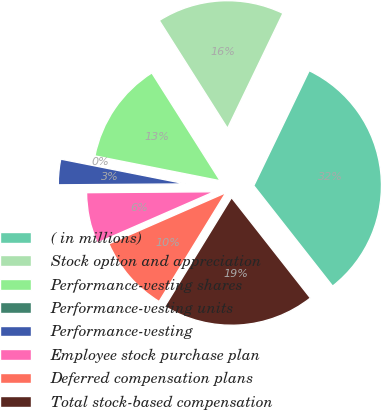<chart> <loc_0><loc_0><loc_500><loc_500><pie_chart><fcel>( in millions)<fcel>Stock option and appreciation<fcel>Performance-vesting shares<fcel>Performance-vesting units<fcel>Performance-vesting<fcel>Employee stock purchase plan<fcel>Deferred compensation plans<fcel>Total stock-based compensation<nl><fcel>32.26%<fcel>16.13%<fcel>12.9%<fcel>0.0%<fcel>3.23%<fcel>6.45%<fcel>9.68%<fcel>19.35%<nl></chart> 